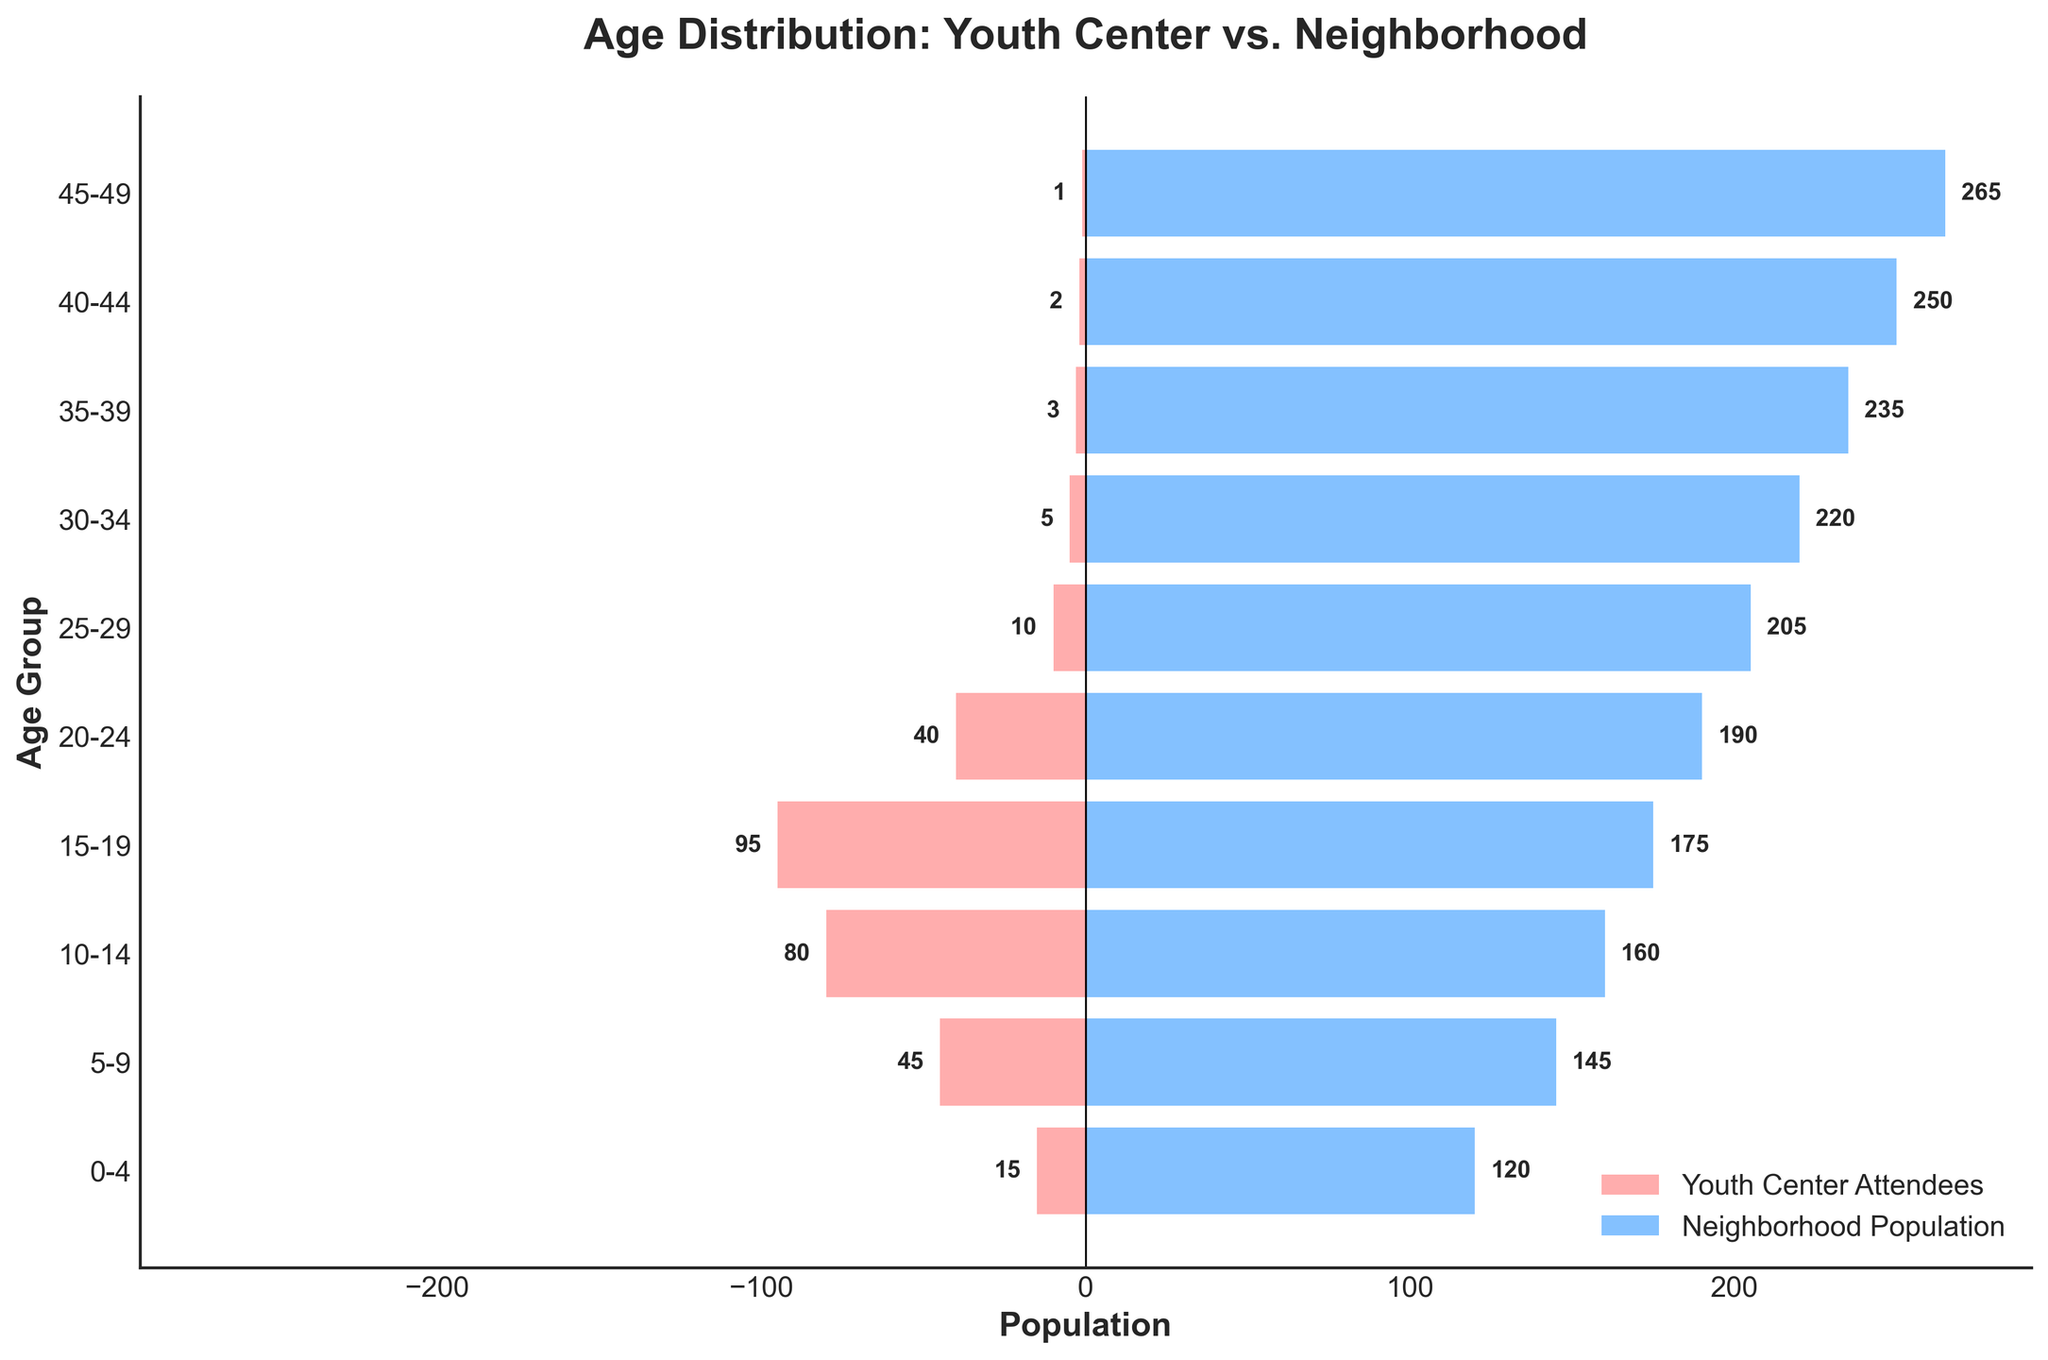How many age groups are displayed in the figure? The figure displays the age distribution across multiple age groups on the y-axis. Counting the different age ranges, we see there are 10 age groups from "0-4" to "45-49".
Answer: 10 What is the title of the figure? The title of the figure is prominently displayed at the top of the chart. It reads "Age Distribution: Youth Center vs. Neighborhood".
Answer: Age Distribution: Youth Center vs. Neighborhood Which age group has the highest number of youth center attendees? By looking at the bars representing youth center attendees, the "15-19" age group has the longest negative bar. This indicates it has the highest number of attendees, which is 95.
Answer: 15-19 How does the number of neighborhood population change as age increases? Observing the bars on the right side, we can see that the neighborhood population generally increases with age, peaking at the "45-49" age group. This indicates a gradual increase in the population numbers.
Answer: Increases What is the difference in the number of attendees between the "15-19" and "20-24" age groups at the youth center? Referring to the length of the bars corresponding to the "15-19" (95 attendees) and "20-24" (40 attendees) age groups, the difference is calculated by subtracting the two values: 95 - 40 = 55.
Answer: 55 How many more people are there in the "40-44" age group in the neighborhood compared to the youth center attendees? The figure shows 250 neighborhood residents in the "40-44" age group and 2 attendees at the youth center. The difference is 250 - 2 = 248.
Answer: 248 What's the proportion of youth center attendees in the "0-4" age group compared to the total attendees represented in the figure? First, we sum all the youth center attendees: 15 + 45 + 80 + 95 + 40 + 10 + 5 + 3 + 2 + 1 = 296. Then we calculate the proportion of attendees in the "0-4" age group: 15 / 296 ≈ 0.0507 or 5.07%.
Answer: 5.07% Which age group has the smallest difference between youth center attendees and neighborhood population? Evaluating the differences for each age group:
- "0-4" has a difference of 120 - 15 = 105
- "5-9" has a difference of 145 - 45 = 100
- "10-14" has a difference of 160 - 80 = 80
- "15-19" has a difference of 175 - 95 = 80
- "20-24" has a difference of 190 - 40 = 150
- "25-29" has a difference of 205 - 10 = 195
- "30-34" has a difference of 220 - 5 = 215
- "35-39" has a difference of 235 - 3 = 232
- "40-44" has a difference of 250 - 2 = 248
- "45-49" has a difference of 265 - 1 = 264
The smallest difference is found in the "10-14" and "15-19" age groups, both with a difference of 80.
Answer: 10-14, 15-19 What trend can you observe in youth center attendance as age increases? The length of the bars representing youth center attendees generally declines as the age groups progress, indicating a trend of decreasing attendance among older age groups.
Answer: Decreases 